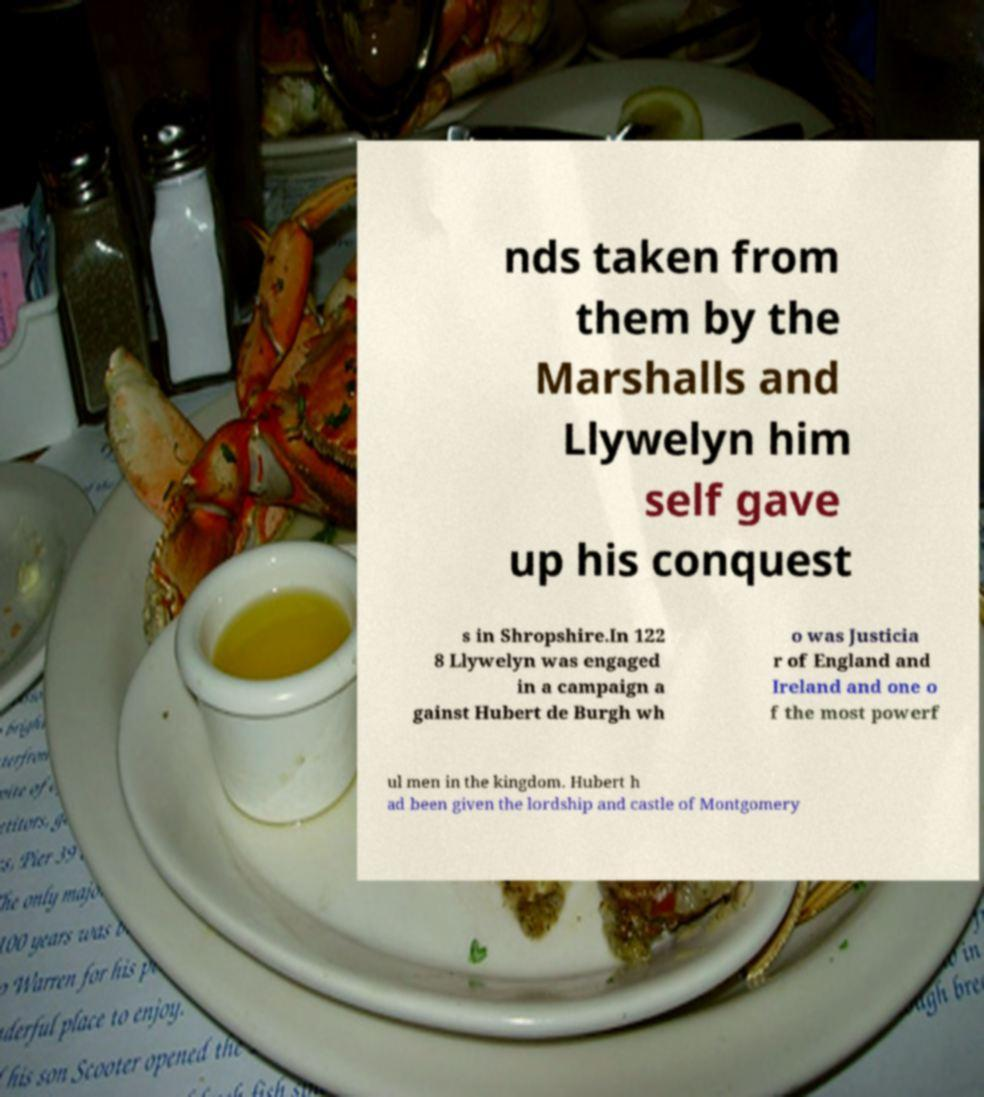I need the written content from this picture converted into text. Can you do that? nds taken from them by the Marshalls and Llywelyn him self gave up his conquest s in Shropshire.In 122 8 Llywelyn was engaged in a campaign a gainst Hubert de Burgh wh o was Justicia r of England and Ireland and one o f the most powerf ul men in the kingdom. Hubert h ad been given the lordship and castle of Montgomery 